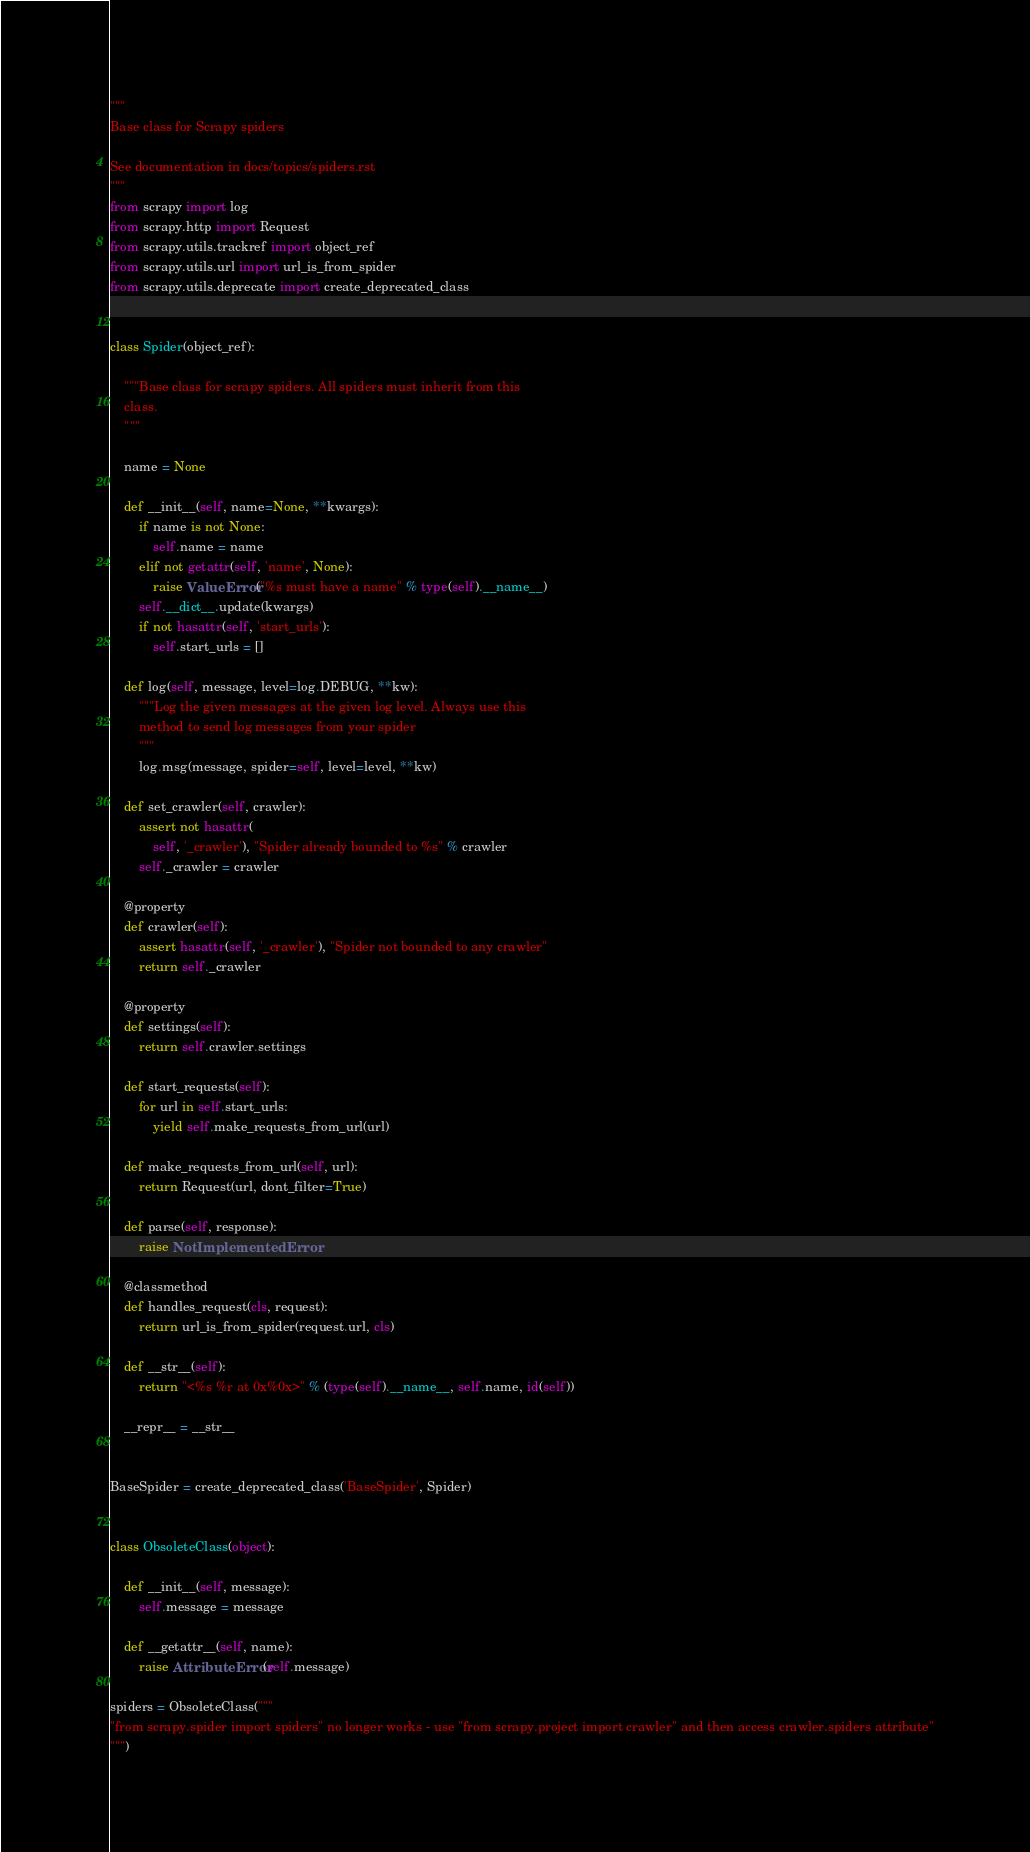Convert code to text. <code><loc_0><loc_0><loc_500><loc_500><_Python_>"""
Base class for Scrapy spiders

See documentation in docs/topics/spiders.rst
"""
from scrapy import log
from scrapy.http import Request
from scrapy.utils.trackref import object_ref
from scrapy.utils.url import url_is_from_spider
from scrapy.utils.deprecate import create_deprecated_class


class Spider(object_ref):

    """Base class for scrapy spiders. All spiders must inherit from this
    class.
    """

    name = None

    def __init__(self, name=None, **kwargs):
        if name is not None:
            self.name = name
        elif not getattr(self, 'name', None):
            raise ValueError("%s must have a name" % type(self).__name__)
        self.__dict__.update(kwargs)
        if not hasattr(self, 'start_urls'):
            self.start_urls = []

    def log(self, message, level=log.DEBUG, **kw):
        """Log the given messages at the given log level. Always use this
        method to send log messages from your spider
        """
        log.msg(message, spider=self, level=level, **kw)

    def set_crawler(self, crawler):
        assert not hasattr(
            self, '_crawler'), "Spider already bounded to %s" % crawler
        self._crawler = crawler

    @property
    def crawler(self):
        assert hasattr(self, '_crawler'), "Spider not bounded to any crawler"
        return self._crawler

    @property
    def settings(self):
        return self.crawler.settings

    def start_requests(self):
        for url in self.start_urls:
            yield self.make_requests_from_url(url)

    def make_requests_from_url(self, url):
        return Request(url, dont_filter=True)

    def parse(self, response):
        raise NotImplementedError

    @classmethod
    def handles_request(cls, request):
        return url_is_from_spider(request.url, cls)

    def __str__(self):
        return "<%s %r at 0x%0x>" % (type(self).__name__, self.name, id(self))

    __repr__ = __str__


BaseSpider = create_deprecated_class('BaseSpider', Spider)


class ObsoleteClass(object):

    def __init__(self, message):
        self.message = message

    def __getattr__(self, name):
        raise AttributeError(self.message)

spiders = ObsoleteClass("""
"from scrapy.spider import spiders" no longer works - use "from scrapy.project import crawler" and then access crawler.spiders attribute"
""")
</code> 